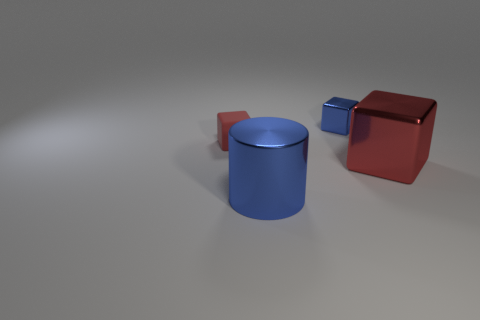Subtract all small red cubes. How many cubes are left? 2 Add 3 tiny blue metal objects. How many objects exist? 7 Subtract all purple cylinders. How many red blocks are left? 2 Subtract all blue blocks. How many blocks are left? 2 Subtract all cylinders. How many objects are left? 3 Subtract 1 cubes. How many cubes are left? 2 Add 1 small blue shiny things. How many small blue shiny things are left? 2 Add 4 tiny red balls. How many tiny red balls exist? 4 Subtract 1 blue cubes. How many objects are left? 3 Subtract all green cubes. Subtract all yellow spheres. How many cubes are left? 3 